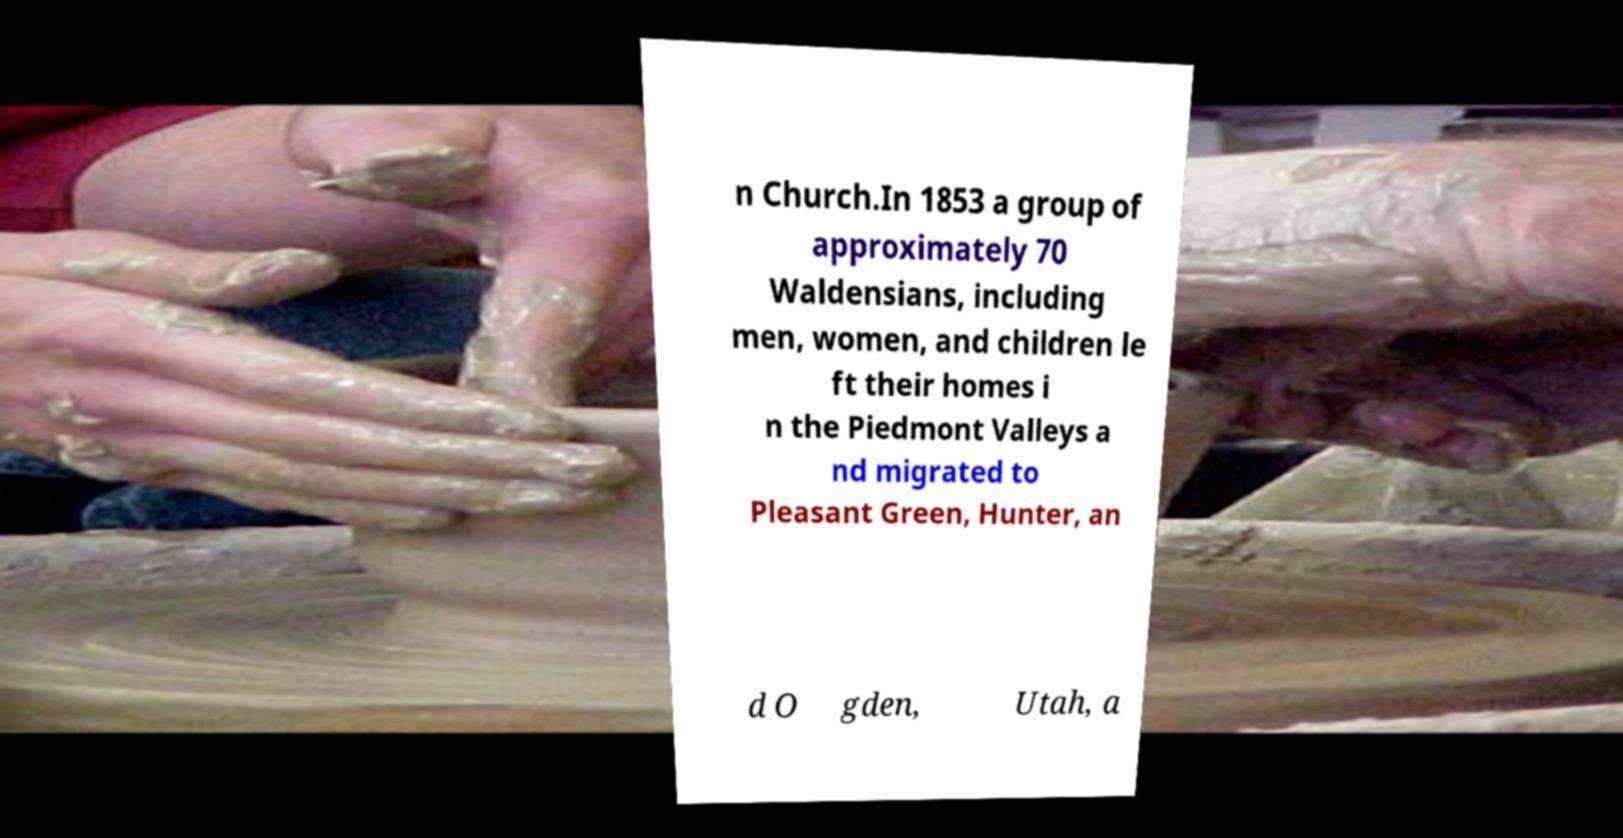Can you read and provide the text displayed in the image?This photo seems to have some interesting text. Can you extract and type it out for me? n Church.In 1853 a group of approximately 70 Waldensians, including men, women, and children le ft their homes i n the Piedmont Valleys a nd migrated to Pleasant Green, Hunter, an d O gden, Utah, a 